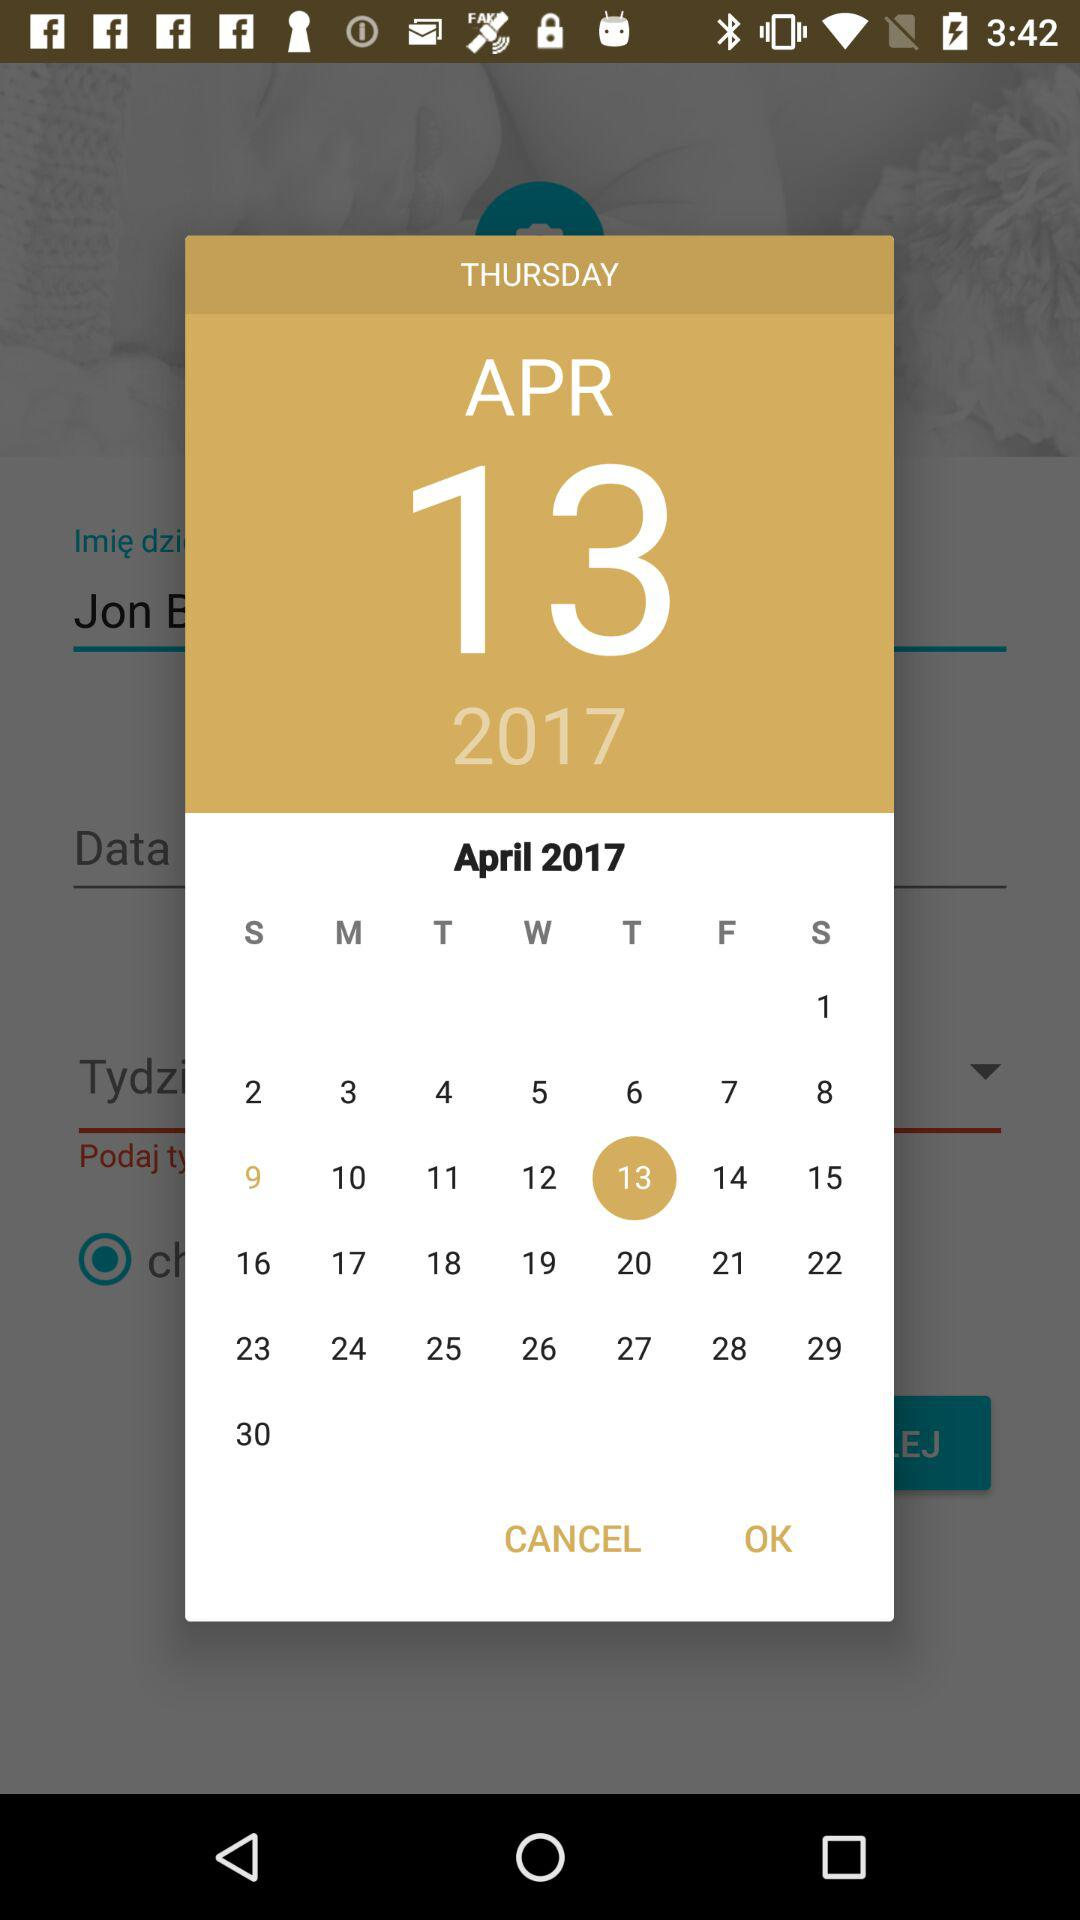What month of the calendar is given on the screen? The given month is April. 